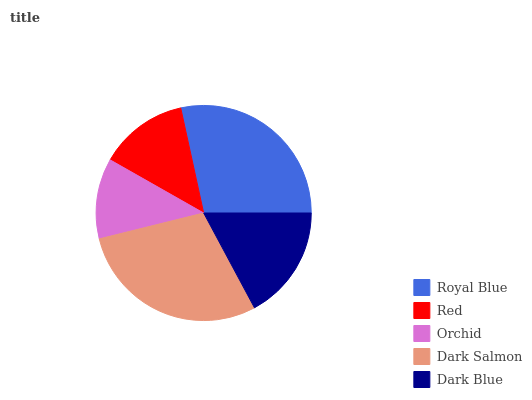Is Orchid the minimum?
Answer yes or no. Yes. Is Dark Salmon the maximum?
Answer yes or no. Yes. Is Red the minimum?
Answer yes or no. No. Is Red the maximum?
Answer yes or no. No. Is Royal Blue greater than Red?
Answer yes or no. Yes. Is Red less than Royal Blue?
Answer yes or no. Yes. Is Red greater than Royal Blue?
Answer yes or no. No. Is Royal Blue less than Red?
Answer yes or no. No. Is Dark Blue the high median?
Answer yes or no. Yes. Is Dark Blue the low median?
Answer yes or no. Yes. Is Red the high median?
Answer yes or no. No. Is Royal Blue the low median?
Answer yes or no. No. 